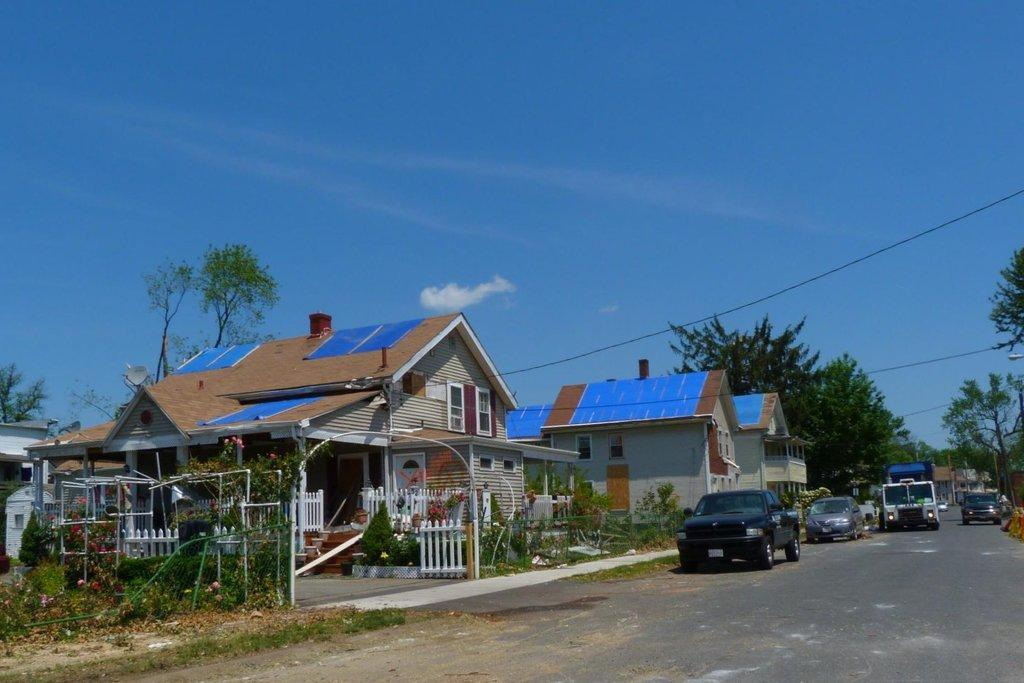What is the main feature of the image? There is a road in the image. What can be seen on the road? There are vehicles parked on the road. What else is visible in the image besides the road and vehicles? There are plants, houses, trees, and the sky visible in the image. What type of shock can be seen affecting the trees in the image? There is no shock affecting the trees in the image; they appear to be normal and healthy. Can you tell me how many pails are being used to water the plants in the image? There are no pails visible in the image; only plants, houses, trees, and the sky are present. 